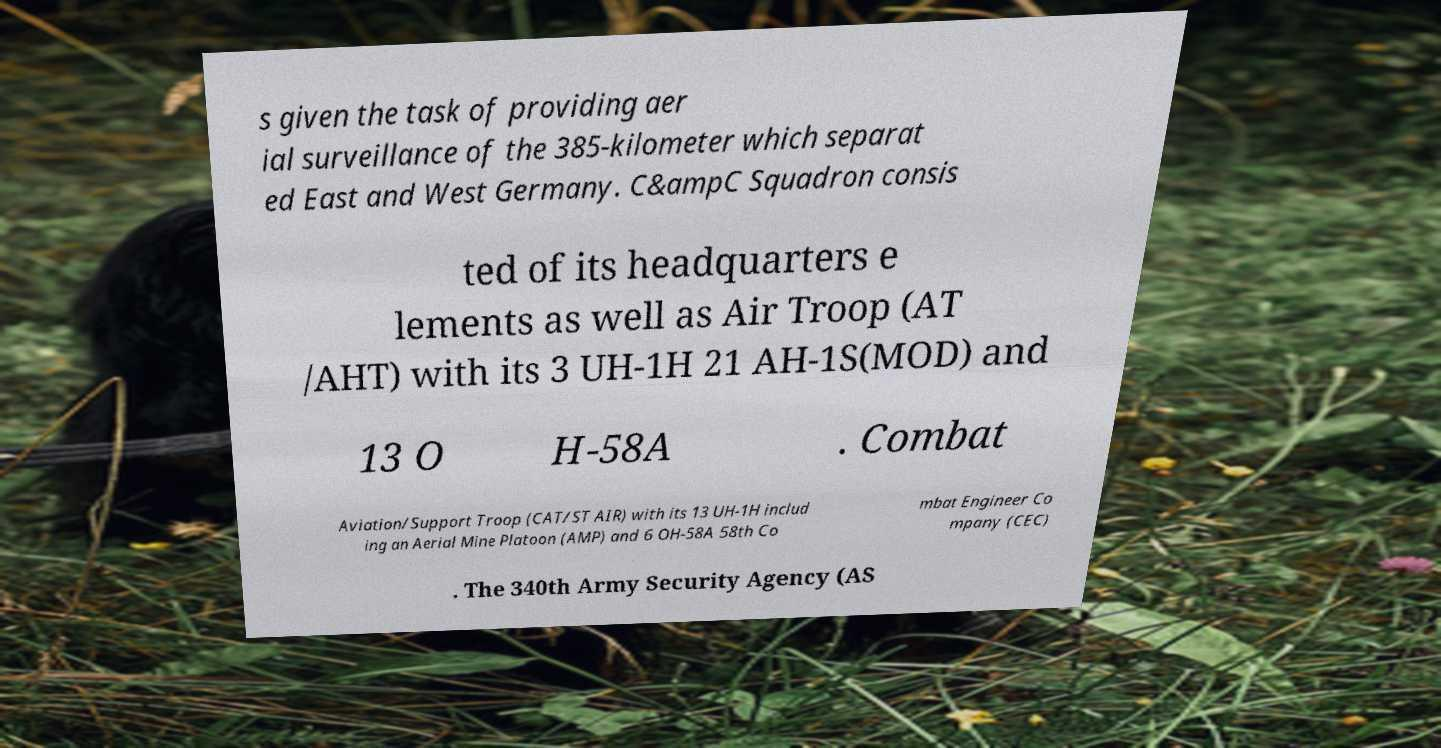Please identify and transcribe the text found in this image. s given the task of providing aer ial surveillance of the 385-kilometer which separat ed East and West Germany. C&ampC Squadron consis ted of its headquarters e lements as well as Air Troop (AT /AHT) with its 3 UH-1H 21 AH-1S(MOD) and 13 O H-58A . Combat Aviation/Support Troop (CAT/ST AIR) with its 13 UH-1H includ ing an Aerial Mine Platoon (AMP) and 6 OH-58A 58th Co mbat Engineer Co mpany (CEC) . The 340th Army Security Agency (AS 